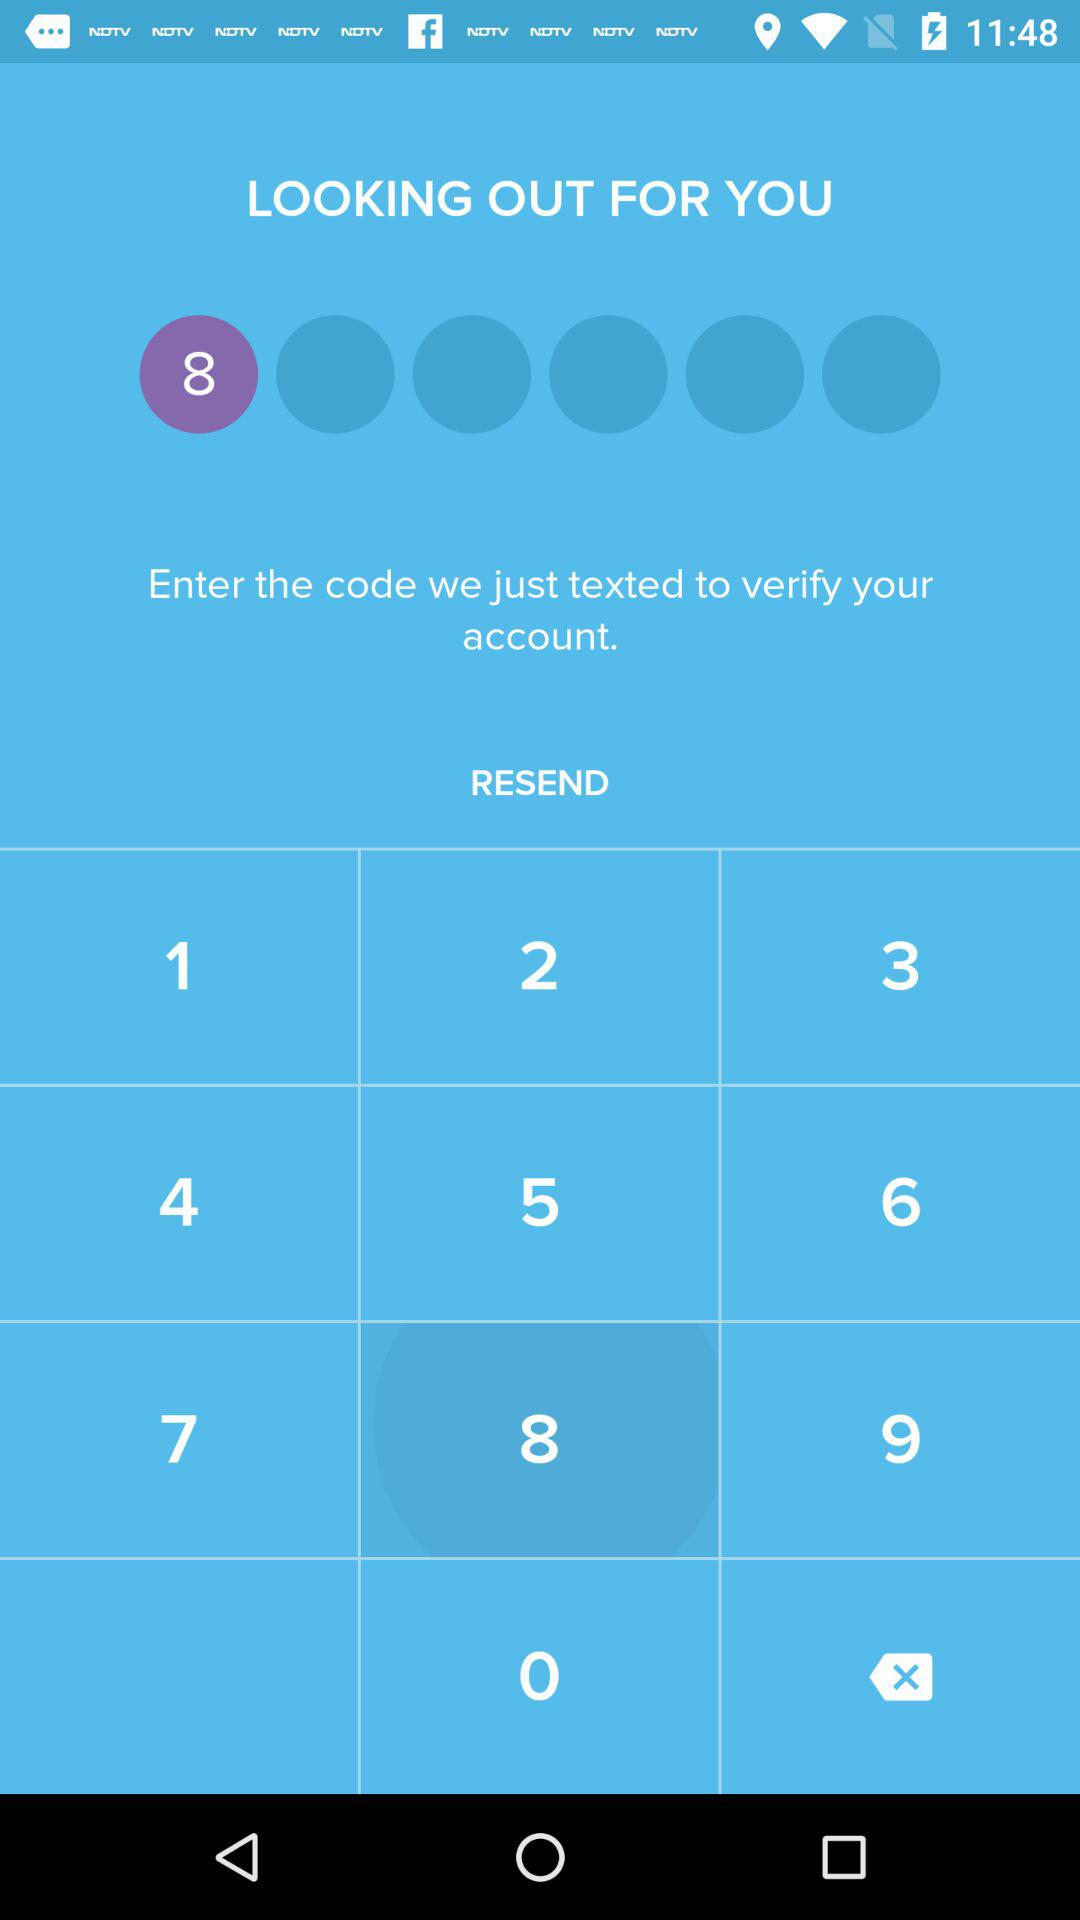What is the first digit of the code which is entered? The first digit of the code is 8. 